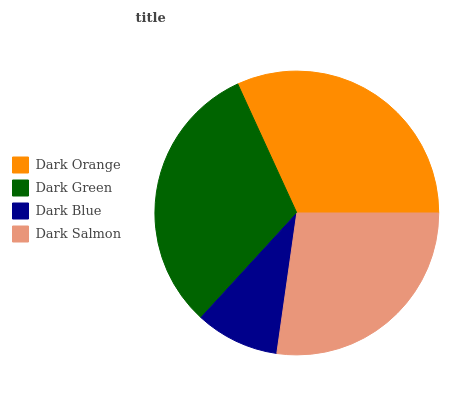Is Dark Blue the minimum?
Answer yes or no. Yes. Is Dark Orange the maximum?
Answer yes or no. Yes. Is Dark Green the minimum?
Answer yes or no. No. Is Dark Green the maximum?
Answer yes or no. No. Is Dark Orange greater than Dark Green?
Answer yes or no. Yes. Is Dark Green less than Dark Orange?
Answer yes or no. Yes. Is Dark Green greater than Dark Orange?
Answer yes or no. No. Is Dark Orange less than Dark Green?
Answer yes or no. No. Is Dark Green the high median?
Answer yes or no. Yes. Is Dark Salmon the low median?
Answer yes or no. Yes. Is Dark Orange the high median?
Answer yes or no. No. Is Dark Green the low median?
Answer yes or no. No. 